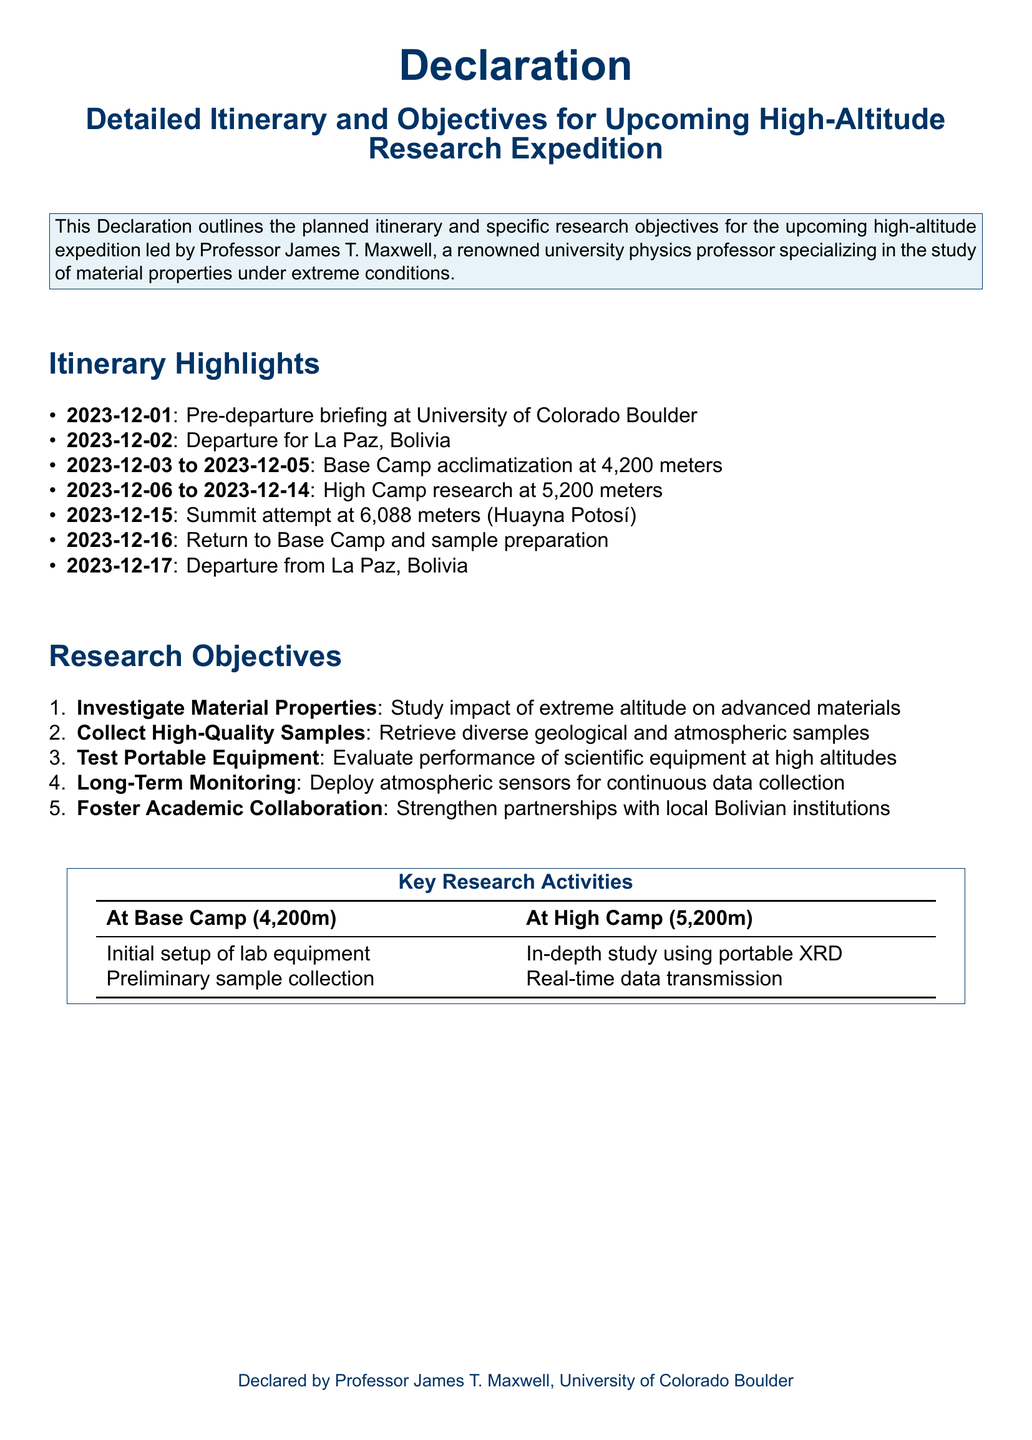What is the departure date for La Paz, Bolivia? The document states that the departure for La Paz, Bolivia is scheduled for 2023-12-02.
Answer: 2023-12-02 How many days will the team spend at High Camp? The itinerary indicates that the team will be at High Camp from 2023-12-06 to 2023-12-14, which is 9 days.
Answer: 9 days What is one of the research objectives listed in the document? The research objectives include investigating material properties, among other goals.
Answer: Investigate Material Properties What is the altitude of the Base Camp? The document specifies that the Base Camp is located at 4,200 meters.
Answer: 4,200 meters Who is leading the expedition? The declaration indicates that the expedition is led by Professor James T. Maxwell.
Answer: Professor James T. Maxwell What type of equipment will be tested during the expedition? According to the research objectives, portable equipment will be tested at high altitudes.
Answer: Portable Equipment What is one of the key research activities at Base Camp? The document mentions that initial setup of lab equipment is a key activity at Base Camp.
Answer: Initial setup of lab equipment What is the date of the summit attempt? The summit attempt is planned for 2023-12-15.
Answer: 2023-12-15 What institution is Professor Maxwell affiliated with? The document states that Professor James T. Maxwell is affiliated with the University of Colorado Boulder.
Answer: University of Colorado Boulder 